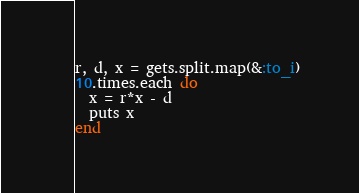<code> <loc_0><loc_0><loc_500><loc_500><_Ruby_>r, d, x = gets.split.map(&:to_i)
10.times.each do
  x = r*x - d
  puts x
end
</code> 